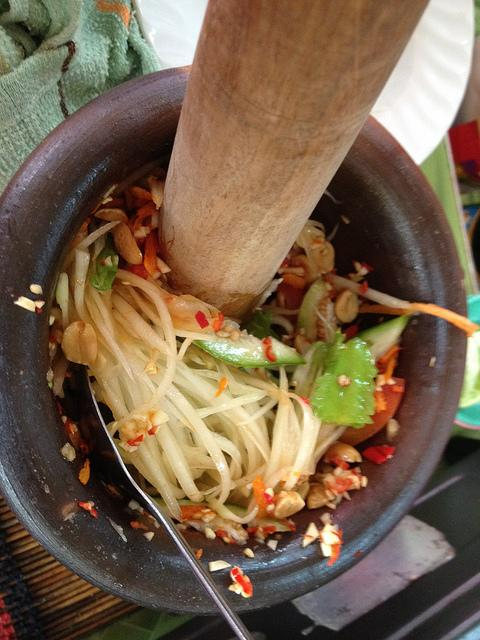What is the use of the pestle and mortar in the picture above? Please explain your reasoning. smash contents. A pestle and mortar is used to smash ingredients. 